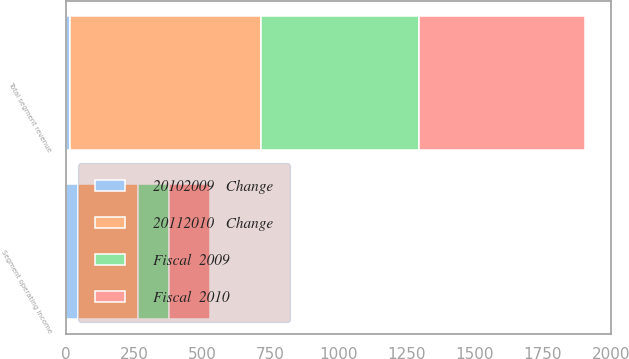<chart> <loc_0><loc_0><loc_500><loc_500><stacked_bar_chart><ecel><fcel>Total segment revenue<fcel>Segment operating income<nl><fcel>20112010   Change<fcel>701<fcel>220<nl><fcel>Fiscal  2010<fcel>611<fcel>152<nl><fcel>Fiscal  2009<fcel>579<fcel>113<nl><fcel>20102009   Change<fcel>15<fcel>44<nl></chart> 